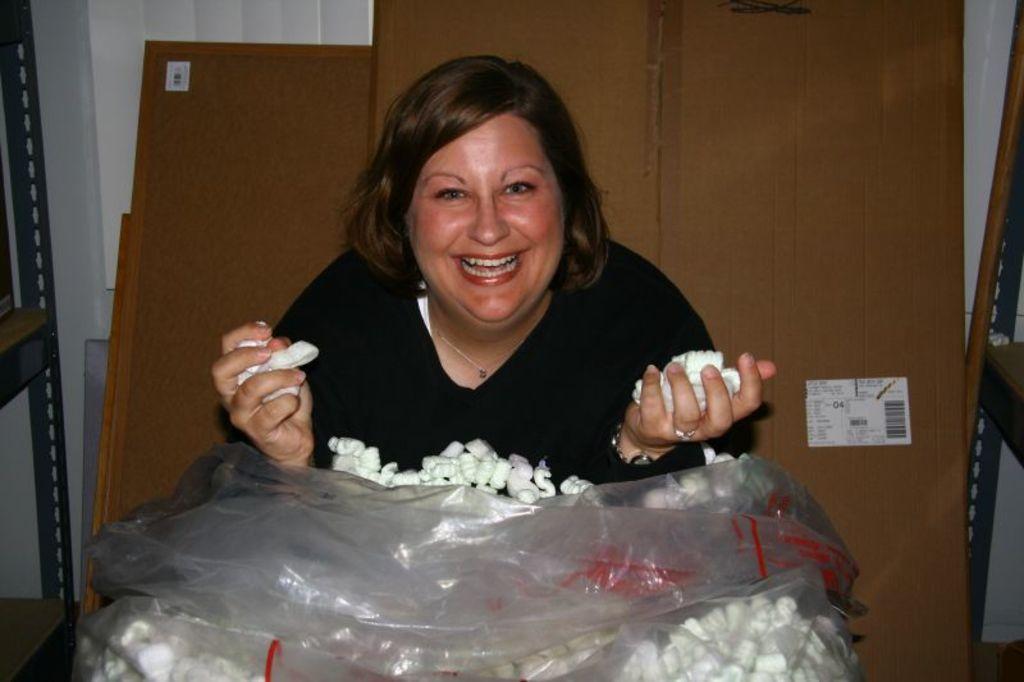Could you give a brief overview of what you see in this image? In the given picture, I can see a women sitting and holding few objects, Behind the women, I can see few doors and in front of women a plastic bag which is filled with an objects and behind the doors, I can see a white color curtains and towards left, I can see a rack and towards right, I can see another rack. 